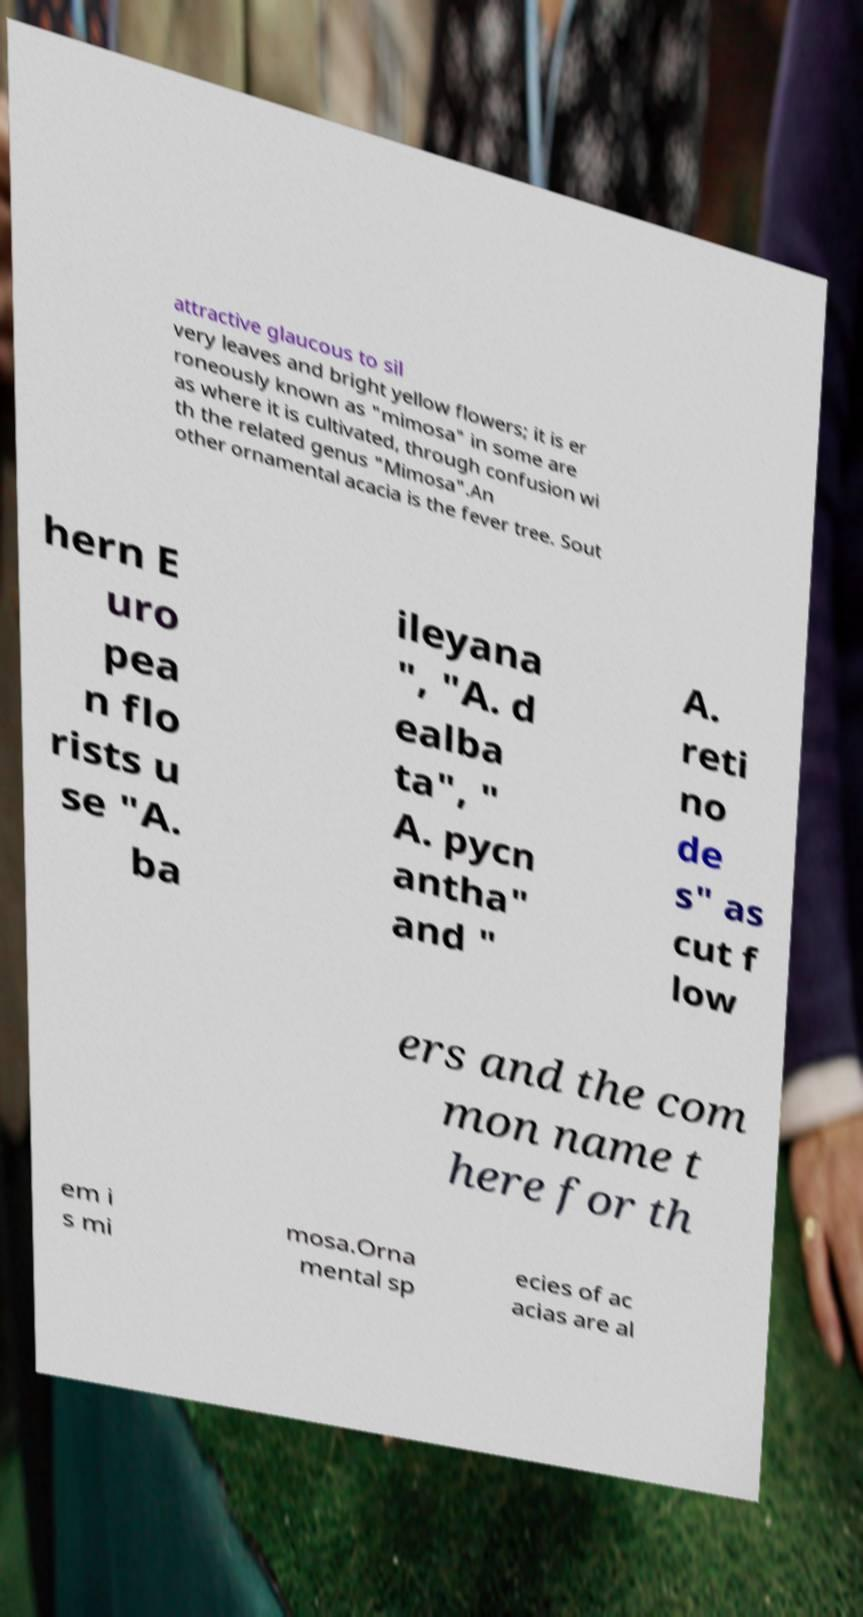There's text embedded in this image that I need extracted. Can you transcribe it verbatim? attractive glaucous to sil very leaves and bright yellow flowers; it is er roneously known as "mimosa" in some are as where it is cultivated, through confusion wi th the related genus "Mimosa".An other ornamental acacia is the fever tree. Sout hern E uro pea n flo rists u se "A. ba ileyana ", "A. d ealba ta", " A. pycn antha" and " A. reti no de s" as cut f low ers and the com mon name t here for th em i s mi mosa.Orna mental sp ecies of ac acias are al 